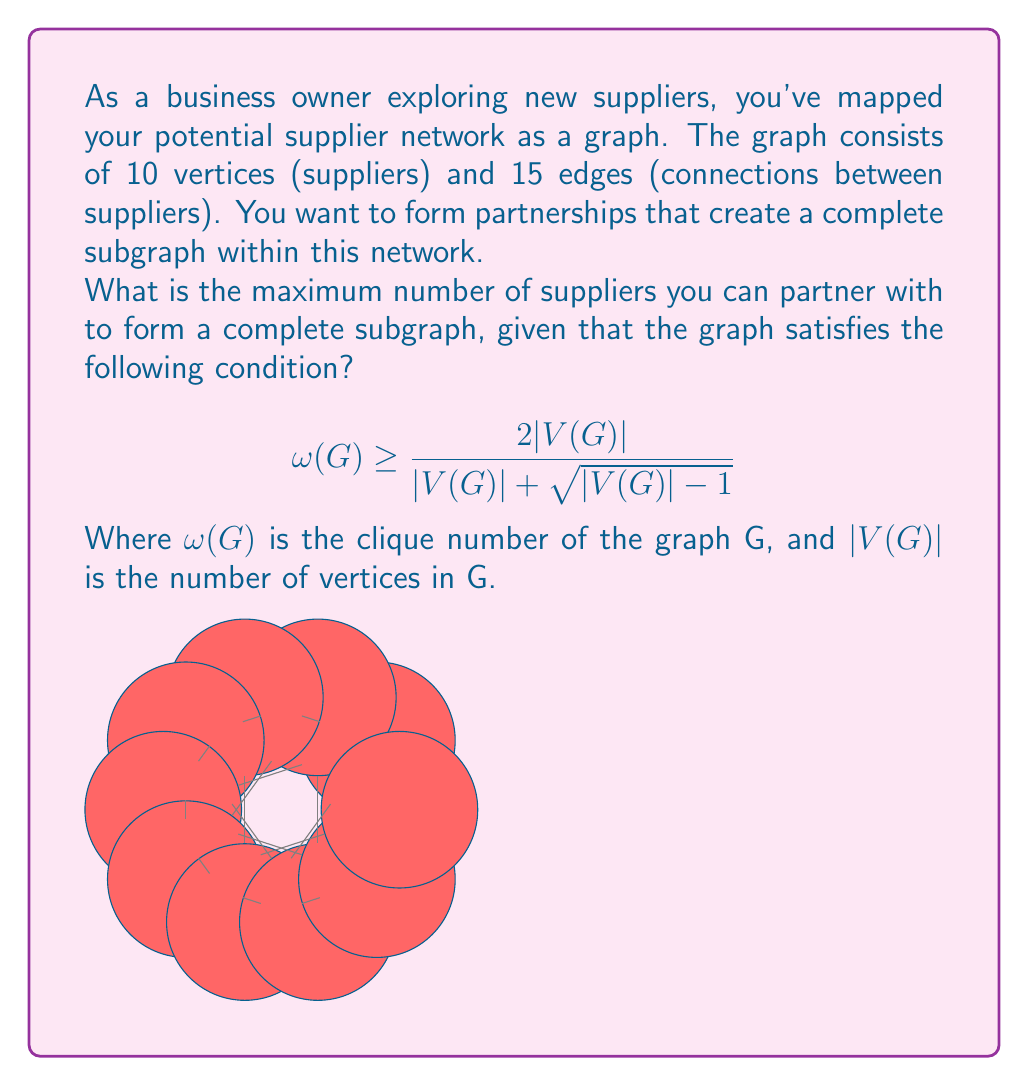Help me with this question. Let's approach this step-by-step:

1) First, we need to understand what the given condition means:

   $$\omega(G) \geq \frac{2|V(G)|}{|V(G)| + \sqrt{|V(G)| - 1}}$$

   This is known as Turán's theorem, which provides a lower bound for the clique number of a graph.

2) We're given that $|V(G)| = 10$ (10 suppliers). Let's substitute this into the inequality:

   $$\omega(G) \geq \frac{2(10)}{10 + \sqrt{10 - 1}} = \frac{20}{10 + 3} = \frac{20}{13} \approx 1.54$$

3) Since $\omega(G)$ must be an integer (it represents the size of the largest complete subgraph), we round up to get:

   $$\omega(G) \geq 2$$

4) This means that the graph is guaranteed to have a complete subgraph of at least 2 vertices. However, this is just a lower bound.

5) To find the maximum possible size of a complete subgraph, we need to consider the number of edges in the graph. We're given that there are 15 edges.

6) The maximum number of edges in a complete graph with $n$ vertices is $\binom{n}{2} = \frac{n(n-1)}{2}$.

7) We need to find the largest $n$ such that $\frac{n(n-1)}{2} \leq 15$.

8) Solving this inequality:
   $n^2 - n - 30 \leq 0$
   $(n-6)(n+5) \leq 0$
   $-5 \leq n \leq 6$

9) Since $n$ represents the number of vertices and must be positive, the largest possible value for $n$ is 5.

Therefore, the maximum number of suppliers you can partner with to form a complete subgraph is 5.
Answer: 5 suppliers 